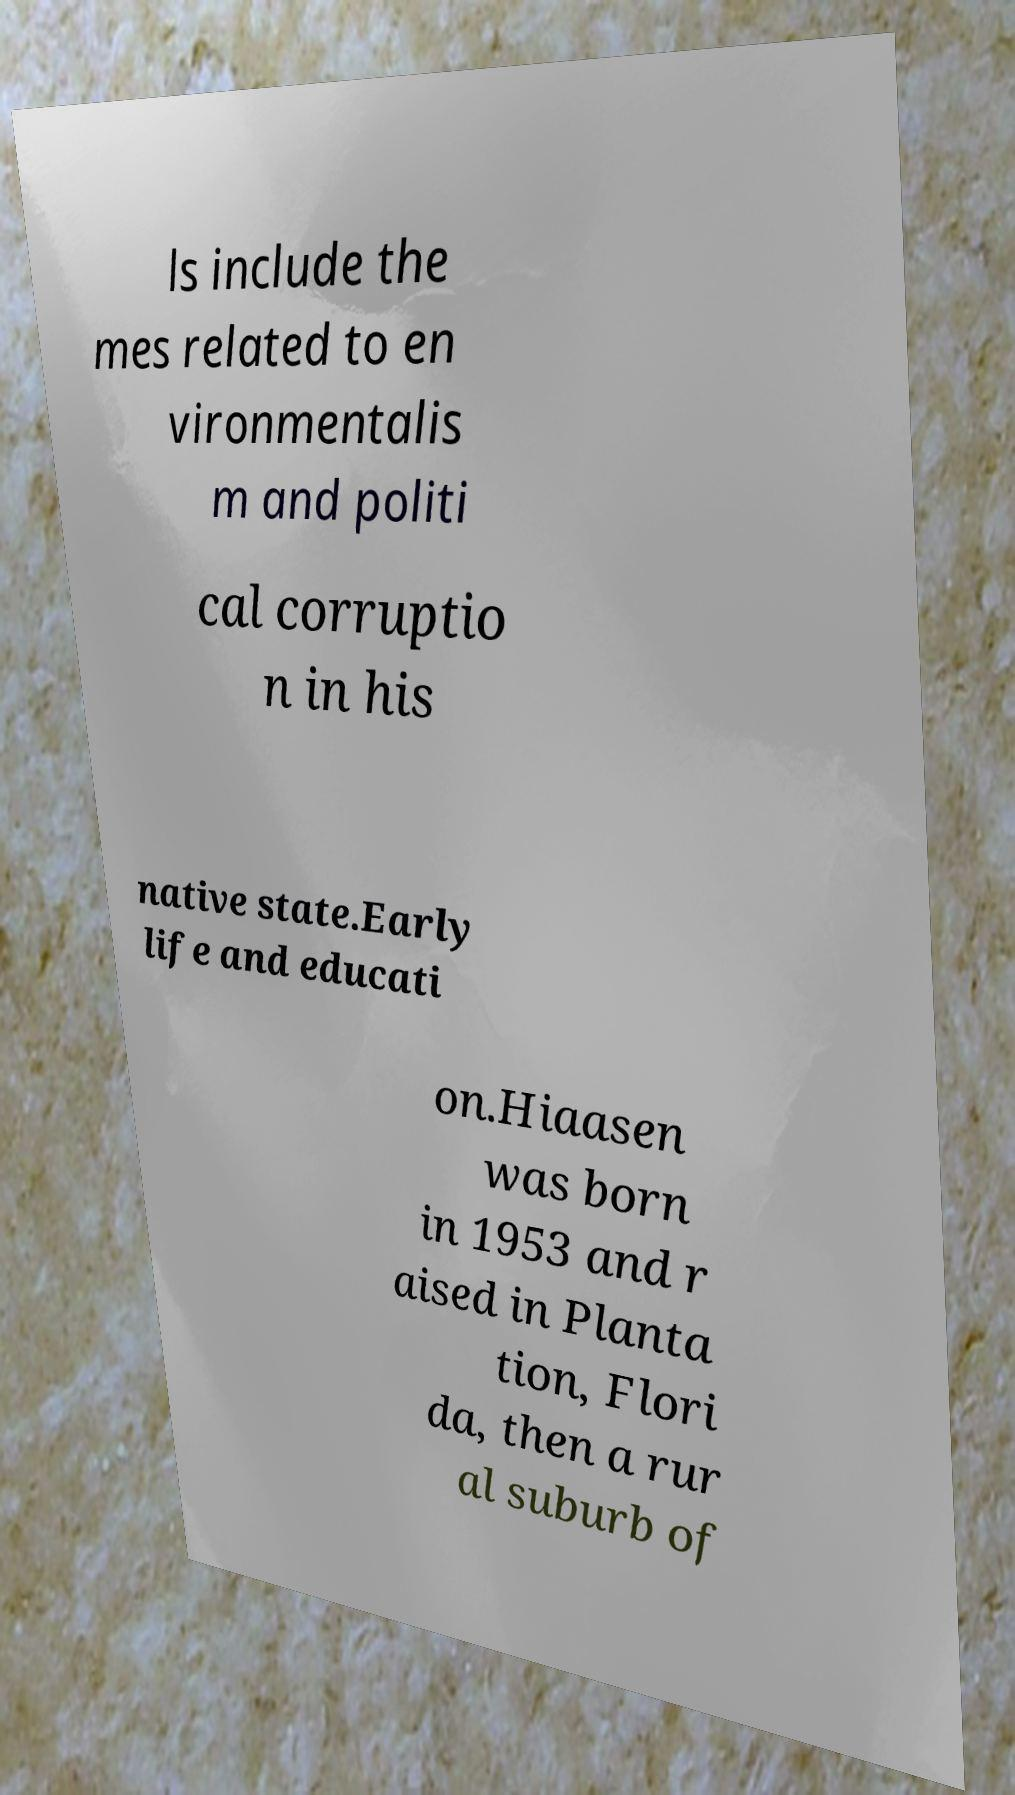Can you read and provide the text displayed in the image?This photo seems to have some interesting text. Can you extract and type it out for me? ls include the mes related to en vironmentalis m and politi cal corruptio n in his native state.Early life and educati on.Hiaasen was born in 1953 and r aised in Planta tion, Flori da, then a rur al suburb of 